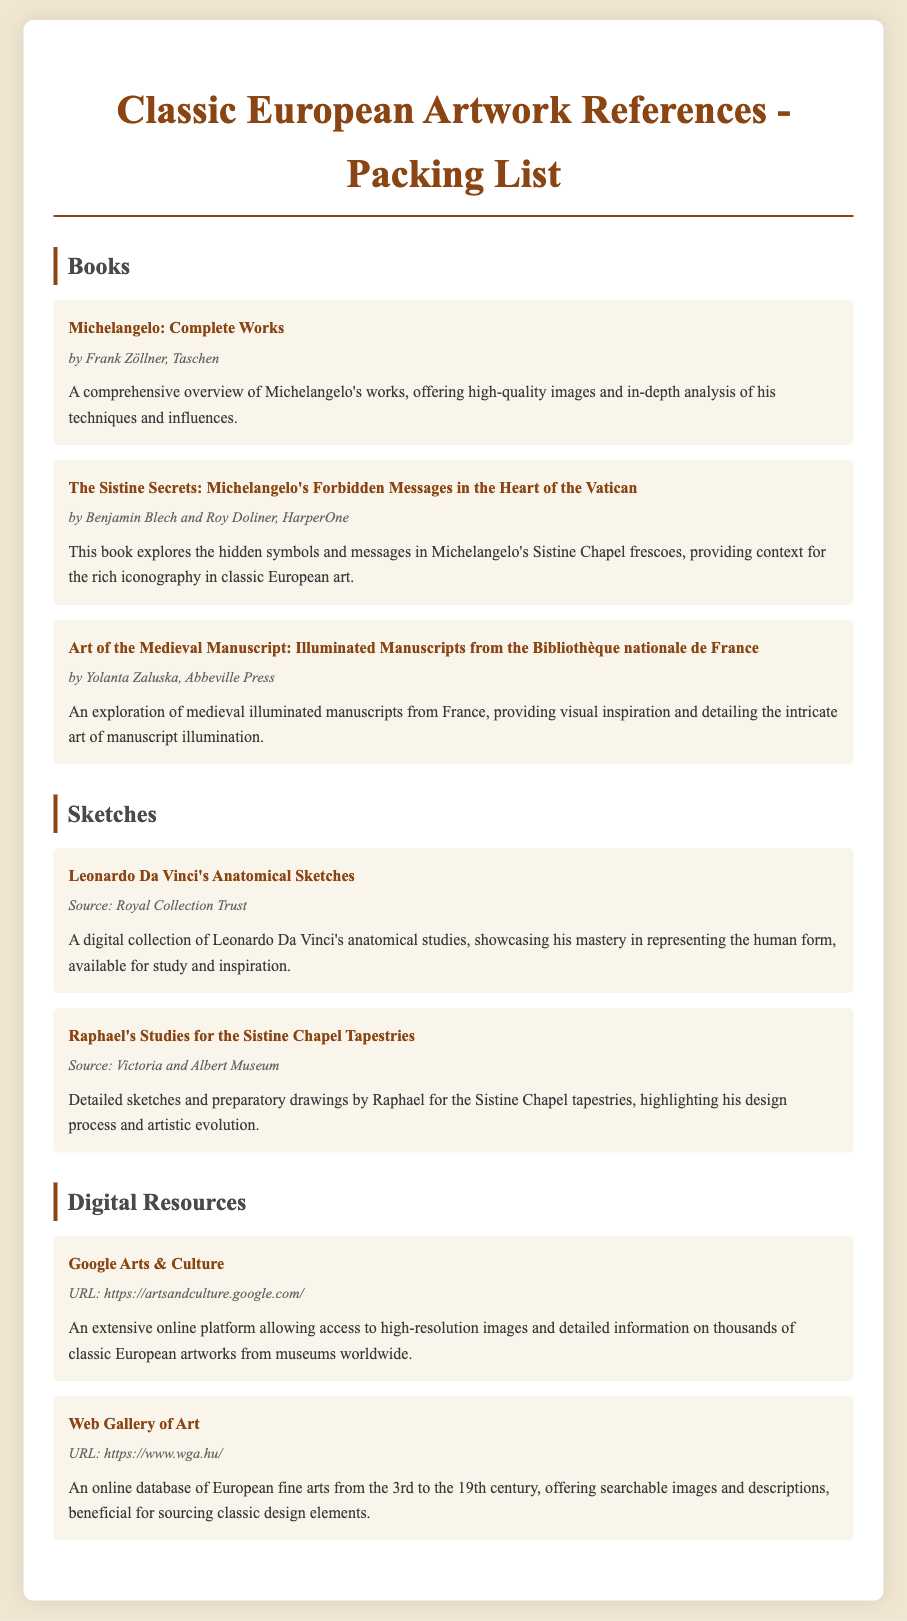what is the title of the first book listed? The title of the first book mentioned in the document is found under the "Books" section.
Answer: Michelangelo: Complete Works who is the author of "The Sistine Secrets"? The author's name is specified along with the title of the book under the "Books" section.
Answer: Benjamin Blech and Roy Doliner how many sketches are listed in the document? The number of sketches can be determined by counting the entries under the "Sketches" section.
Answer: 2 what is the URL for Google Arts & Culture? The URL for Google Arts & Culture is provided explicitly in the "Digital Resources" section.
Answer: https://artsandculture.google.com/ which museum is associated with Raphael's Studies for the Sistine Chapel Tapestries? The specific museum is mentioned in relation to the item description in the "Sketches" section.
Answer: Victoria and Albert Museum what type of resources are included in this packing list? The categories of items are clearly outlined as "Books," "Sketches," and "Digital Resources."
Answer: Books, Sketches, Digital Resources what is the primary theme of the listed resources? The common subject of the provided resources is inferred from the headings and item content within the document.
Answer: Classic European Artwork 